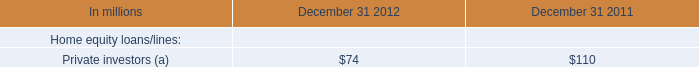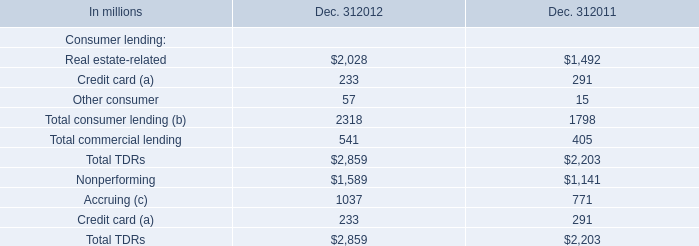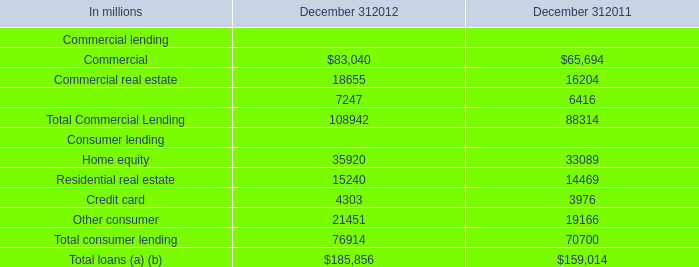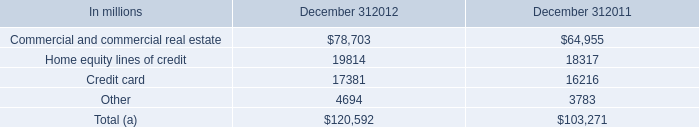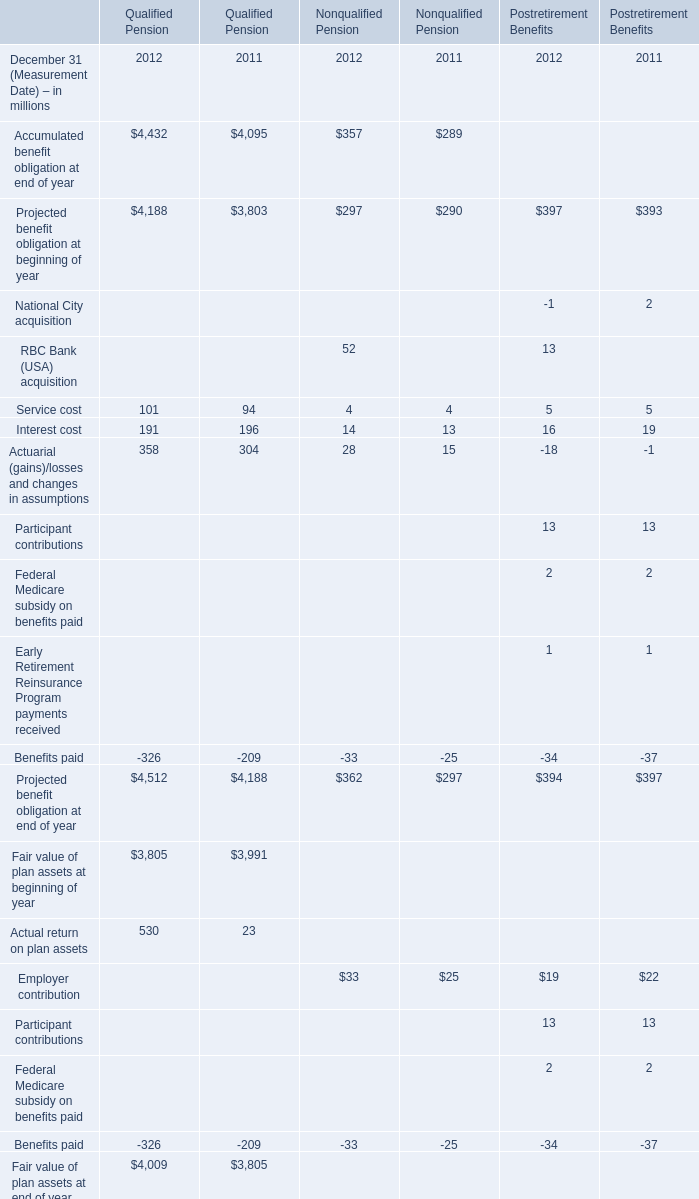What will Interest cost for Qualified Pension be like in2013 if it develops with the same increasing rate as current? (in million) 
Computations: (191 * (1 + ((191 - 196) / 196)))
Answer: 186.12755. 